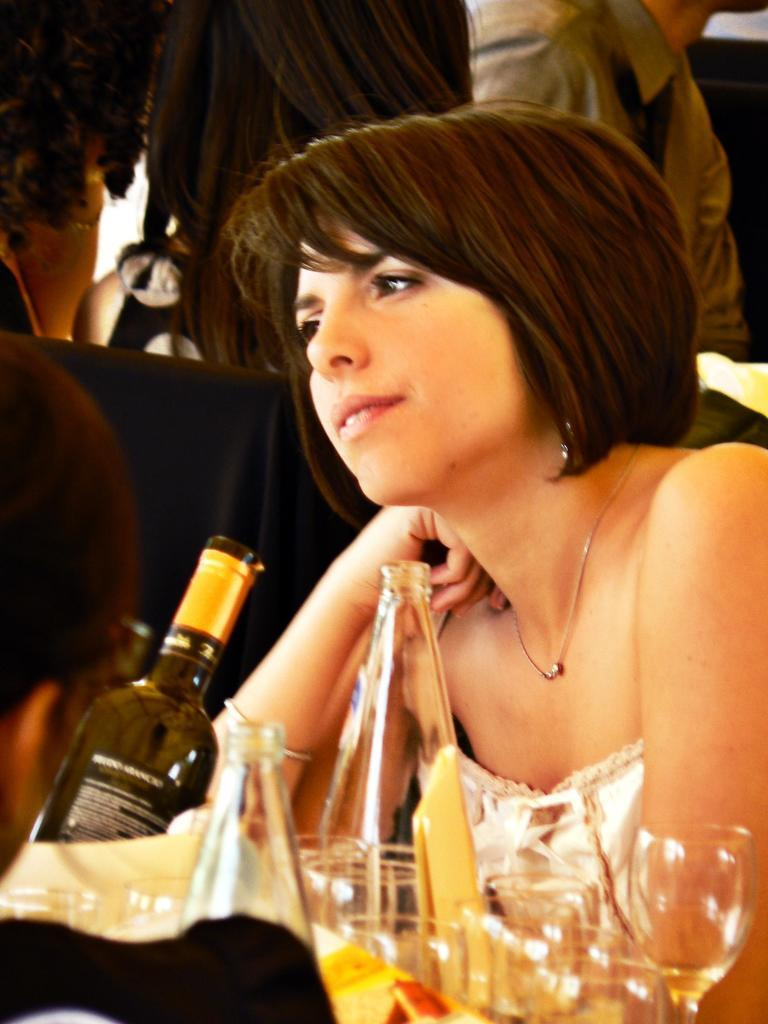What is the woman in the image doing? The woman is sitting in the image. What expression does the woman have? The woman is smiling. What is located in front of the woman? There is a wine bottle and wine glasses in front of her. Can you describe the people in the background of the image? There are people sitting in the background of the image. What type of legal advice is the woman providing in the image? There is no indication in the image that the woman is providing legal advice, as she is sitting and smiling with wine-related items in front of her. 